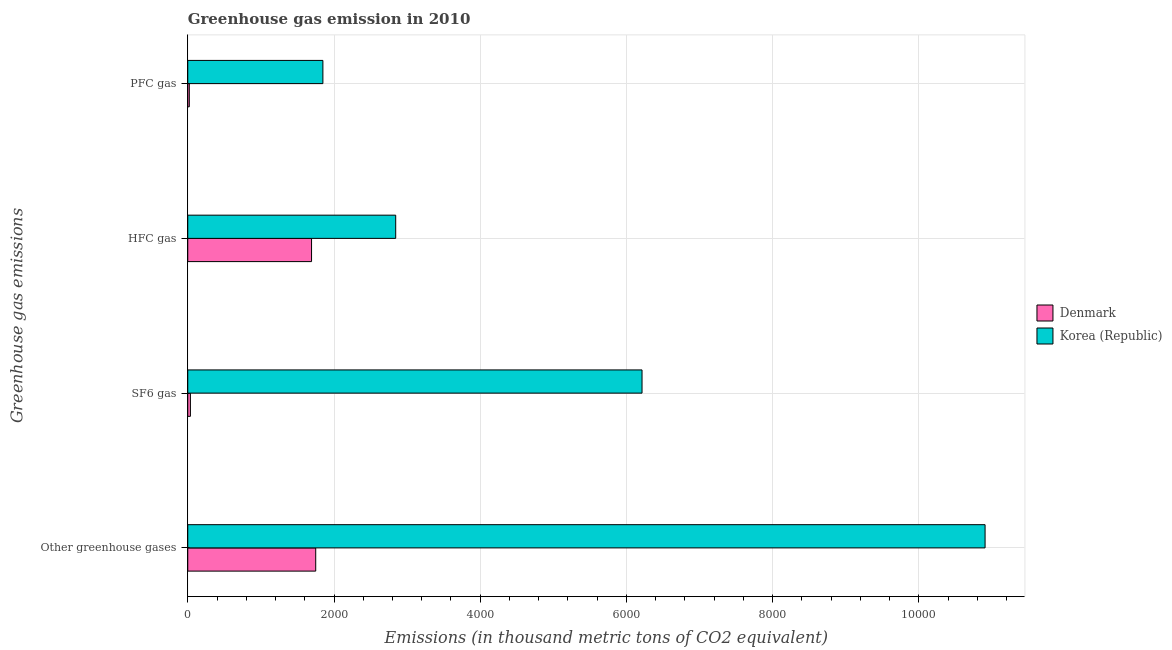How many groups of bars are there?
Ensure brevity in your answer.  4. Are the number of bars per tick equal to the number of legend labels?
Give a very brief answer. Yes. How many bars are there on the 2nd tick from the bottom?
Ensure brevity in your answer.  2. What is the label of the 1st group of bars from the top?
Keep it short and to the point. PFC gas. What is the emission of pfc gas in Korea (Republic)?
Offer a very short reply. 1848. Across all countries, what is the maximum emission of greenhouse gases?
Provide a succinct answer. 1.09e+04. Across all countries, what is the minimum emission of pfc gas?
Make the answer very short. 21. In which country was the emission of sf6 gas minimum?
Offer a terse response. Denmark. What is the total emission of sf6 gas in the graph?
Make the answer very short. 6249. What is the difference between the emission of greenhouse gases in Korea (Republic) and that in Denmark?
Offer a terse response. 9155. What is the difference between the emission of hfc gas in Korea (Republic) and the emission of pfc gas in Denmark?
Provide a succinct answer. 2823. What is the average emission of hfc gas per country?
Provide a short and direct response. 2268.5. What is the difference between the emission of greenhouse gases and emission of hfc gas in Denmark?
Provide a short and direct response. 57. In how many countries, is the emission of sf6 gas greater than 3200 thousand metric tons?
Offer a very short reply. 1. What is the ratio of the emission of hfc gas in Korea (Republic) to that in Denmark?
Keep it short and to the point. 1.68. Is the emission of pfc gas in Korea (Republic) less than that in Denmark?
Ensure brevity in your answer.  No. What is the difference between the highest and the second highest emission of hfc gas?
Your answer should be very brief. 1151. What is the difference between the highest and the lowest emission of sf6 gas?
Your response must be concise. 6177. Is it the case that in every country, the sum of the emission of hfc gas and emission of sf6 gas is greater than the sum of emission of greenhouse gases and emission of pfc gas?
Provide a succinct answer. No. What does the 2nd bar from the bottom in Other greenhouse gases represents?
Ensure brevity in your answer.  Korea (Republic). How many countries are there in the graph?
Your answer should be compact. 2. Are the values on the major ticks of X-axis written in scientific E-notation?
Offer a very short reply. No. Does the graph contain any zero values?
Provide a succinct answer. No. What is the title of the graph?
Your answer should be compact. Greenhouse gas emission in 2010. Does "East Asia (developing only)" appear as one of the legend labels in the graph?
Provide a succinct answer. No. What is the label or title of the X-axis?
Ensure brevity in your answer.  Emissions (in thousand metric tons of CO2 equivalent). What is the label or title of the Y-axis?
Your response must be concise. Greenhouse gas emissions. What is the Emissions (in thousand metric tons of CO2 equivalent) in Denmark in Other greenhouse gases?
Your answer should be very brief. 1750. What is the Emissions (in thousand metric tons of CO2 equivalent) in Korea (Republic) in Other greenhouse gases?
Your answer should be very brief. 1.09e+04. What is the Emissions (in thousand metric tons of CO2 equivalent) of Denmark in SF6 gas?
Provide a short and direct response. 36. What is the Emissions (in thousand metric tons of CO2 equivalent) in Korea (Republic) in SF6 gas?
Keep it short and to the point. 6213. What is the Emissions (in thousand metric tons of CO2 equivalent) in Denmark in HFC gas?
Ensure brevity in your answer.  1693. What is the Emissions (in thousand metric tons of CO2 equivalent) in Korea (Republic) in HFC gas?
Offer a terse response. 2844. What is the Emissions (in thousand metric tons of CO2 equivalent) in Korea (Republic) in PFC gas?
Offer a very short reply. 1848. Across all Greenhouse gas emissions, what is the maximum Emissions (in thousand metric tons of CO2 equivalent) of Denmark?
Your answer should be very brief. 1750. Across all Greenhouse gas emissions, what is the maximum Emissions (in thousand metric tons of CO2 equivalent) in Korea (Republic)?
Make the answer very short. 1.09e+04. Across all Greenhouse gas emissions, what is the minimum Emissions (in thousand metric tons of CO2 equivalent) in Korea (Republic)?
Keep it short and to the point. 1848. What is the total Emissions (in thousand metric tons of CO2 equivalent) in Denmark in the graph?
Provide a succinct answer. 3500. What is the total Emissions (in thousand metric tons of CO2 equivalent) in Korea (Republic) in the graph?
Give a very brief answer. 2.18e+04. What is the difference between the Emissions (in thousand metric tons of CO2 equivalent) in Denmark in Other greenhouse gases and that in SF6 gas?
Provide a short and direct response. 1714. What is the difference between the Emissions (in thousand metric tons of CO2 equivalent) of Korea (Republic) in Other greenhouse gases and that in SF6 gas?
Provide a short and direct response. 4692. What is the difference between the Emissions (in thousand metric tons of CO2 equivalent) of Denmark in Other greenhouse gases and that in HFC gas?
Your response must be concise. 57. What is the difference between the Emissions (in thousand metric tons of CO2 equivalent) of Korea (Republic) in Other greenhouse gases and that in HFC gas?
Give a very brief answer. 8061. What is the difference between the Emissions (in thousand metric tons of CO2 equivalent) of Denmark in Other greenhouse gases and that in PFC gas?
Give a very brief answer. 1729. What is the difference between the Emissions (in thousand metric tons of CO2 equivalent) of Korea (Republic) in Other greenhouse gases and that in PFC gas?
Make the answer very short. 9057. What is the difference between the Emissions (in thousand metric tons of CO2 equivalent) in Denmark in SF6 gas and that in HFC gas?
Ensure brevity in your answer.  -1657. What is the difference between the Emissions (in thousand metric tons of CO2 equivalent) in Korea (Republic) in SF6 gas and that in HFC gas?
Your response must be concise. 3369. What is the difference between the Emissions (in thousand metric tons of CO2 equivalent) in Korea (Republic) in SF6 gas and that in PFC gas?
Keep it short and to the point. 4365. What is the difference between the Emissions (in thousand metric tons of CO2 equivalent) of Denmark in HFC gas and that in PFC gas?
Offer a very short reply. 1672. What is the difference between the Emissions (in thousand metric tons of CO2 equivalent) of Korea (Republic) in HFC gas and that in PFC gas?
Provide a short and direct response. 996. What is the difference between the Emissions (in thousand metric tons of CO2 equivalent) in Denmark in Other greenhouse gases and the Emissions (in thousand metric tons of CO2 equivalent) in Korea (Republic) in SF6 gas?
Provide a short and direct response. -4463. What is the difference between the Emissions (in thousand metric tons of CO2 equivalent) in Denmark in Other greenhouse gases and the Emissions (in thousand metric tons of CO2 equivalent) in Korea (Republic) in HFC gas?
Make the answer very short. -1094. What is the difference between the Emissions (in thousand metric tons of CO2 equivalent) of Denmark in Other greenhouse gases and the Emissions (in thousand metric tons of CO2 equivalent) of Korea (Republic) in PFC gas?
Provide a short and direct response. -98. What is the difference between the Emissions (in thousand metric tons of CO2 equivalent) of Denmark in SF6 gas and the Emissions (in thousand metric tons of CO2 equivalent) of Korea (Republic) in HFC gas?
Give a very brief answer. -2808. What is the difference between the Emissions (in thousand metric tons of CO2 equivalent) of Denmark in SF6 gas and the Emissions (in thousand metric tons of CO2 equivalent) of Korea (Republic) in PFC gas?
Your answer should be compact. -1812. What is the difference between the Emissions (in thousand metric tons of CO2 equivalent) in Denmark in HFC gas and the Emissions (in thousand metric tons of CO2 equivalent) in Korea (Republic) in PFC gas?
Give a very brief answer. -155. What is the average Emissions (in thousand metric tons of CO2 equivalent) of Denmark per Greenhouse gas emissions?
Make the answer very short. 875. What is the average Emissions (in thousand metric tons of CO2 equivalent) of Korea (Republic) per Greenhouse gas emissions?
Your answer should be compact. 5452.5. What is the difference between the Emissions (in thousand metric tons of CO2 equivalent) of Denmark and Emissions (in thousand metric tons of CO2 equivalent) of Korea (Republic) in Other greenhouse gases?
Your response must be concise. -9155. What is the difference between the Emissions (in thousand metric tons of CO2 equivalent) of Denmark and Emissions (in thousand metric tons of CO2 equivalent) of Korea (Republic) in SF6 gas?
Your answer should be very brief. -6177. What is the difference between the Emissions (in thousand metric tons of CO2 equivalent) of Denmark and Emissions (in thousand metric tons of CO2 equivalent) of Korea (Republic) in HFC gas?
Your response must be concise. -1151. What is the difference between the Emissions (in thousand metric tons of CO2 equivalent) of Denmark and Emissions (in thousand metric tons of CO2 equivalent) of Korea (Republic) in PFC gas?
Your response must be concise. -1827. What is the ratio of the Emissions (in thousand metric tons of CO2 equivalent) of Denmark in Other greenhouse gases to that in SF6 gas?
Ensure brevity in your answer.  48.61. What is the ratio of the Emissions (in thousand metric tons of CO2 equivalent) of Korea (Republic) in Other greenhouse gases to that in SF6 gas?
Your answer should be compact. 1.76. What is the ratio of the Emissions (in thousand metric tons of CO2 equivalent) of Denmark in Other greenhouse gases to that in HFC gas?
Your answer should be compact. 1.03. What is the ratio of the Emissions (in thousand metric tons of CO2 equivalent) in Korea (Republic) in Other greenhouse gases to that in HFC gas?
Your answer should be compact. 3.83. What is the ratio of the Emissions (in thousand metric tons of CO2 equivalent) of Denmark in Other greenhouse gases to that in PFC gas?
Your response must be concise. 83.33. What is the ratio of the Emissions (in thousand metric tons of CO2 equivalent) in Korea (Republic) in Other greenhouse gases to that in PFC gas?
Offer a terse response. 5.9. What is the ratio of the Emissions (in thousand metric tons of CO2 equivalent) in Denmark in SF6 gas to that in HFC gas?
Your answer should be very brief. 0.02. What is the ratio of the Emissions (in thousand metric tons of CO2 equivalent) of Korea (Republic) in SF6 gas to that in HFC gas?
Give a very brief answer. 2.18. What is the ratio of the Emissions (in thousand metric tons of CO2 equivalent) in Denmark in SF6 gas to that in PFC gas?
Offer a very short reply. 1.71. What is the ratio of the Emissions (in thousand metric tons of CO2 equivalent) in Korea (Republic) in SF6 gas to that in PFC gas?
Offer a very short reply. 3.36. What is the ratio of the Emissions (in thousand metric tons of CO2 equivalent) in Denmark in HFC gas to that in PFC gas?
Offer a terse response. 80.62. What is the ratio of the Emissions (in thousand metric tons of CO2 equivalent) of Korea (Republic) in HFC gas to that in PFC gas?
Provide a succinct answer. 1.54. What is the difference between the highest and the second highest Emissions (in thousand metric tons of CO2 equivalent) in Korea (Republic)?
Ensure brevity in your answer.  4692. What is the difference between the highest and the lowest Emissions (in thousand metric tons of CO2 equivalent) in Denmark?
Provide a short and direct response. 1729. What is the difference between the highest and the lowest Emissions (in thousand metric tons of CO2 equivalent) of Korea (Republic)?
Make the answer very short. 9057. 